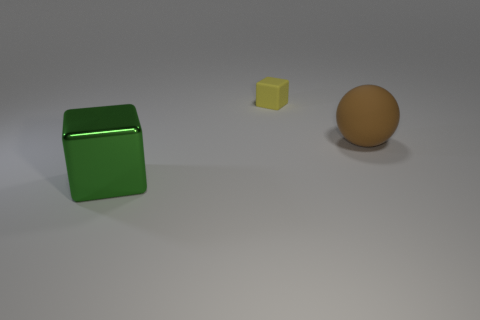Is the number of large things less than the number of purple rubber cubes?
Keep it short and to the point. No. What is the color of the other thing that is the same shape as the large shiny object?
Your answer should be very brief. Yellow. Are there any other things that are the same shape as the tiny matte object?
Your response must be concise. Yes. Are there more large green things than tiny metallic cylinders?
Give a very brief answer. Yes. What number of other things are made of the same material as the brown ball?
Offer a very short reply. 1. What is the shape of the large thing to the left of the big thing behind the object in front of the brown rubber object?
Provide a short and direct response. Cube. Are there fewer yellow matte cubes to the left of the metal thing than big rubber things that are behind the tiny yellow rubber cube?
Keep it short and to the point. No. Is there a rubber block of the same color as the small rubber object?
Give a very brief answer. No. Are the large brown object and the block that is behind the brown sphere made of the same material?
Your answer should be compact. Yes. There is a large thing on the left side of the small object; are there any things to the left of it?
Keep it short and to the point. No. 